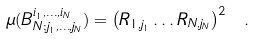Convert formula to latex. <formula><loc_0><loc_0><loc_500><loc_500>\mu ( B _ { N ; j _ { 1 } , \dots , j _ { N } } ^ { i _ { 1 } , \dots , i _ { N } } ) = \left ( R _ { 1 , j _ { 1 } } \dots R _ { N , j _ { N } } \right ) ^ { 2 } \ .</formula> 